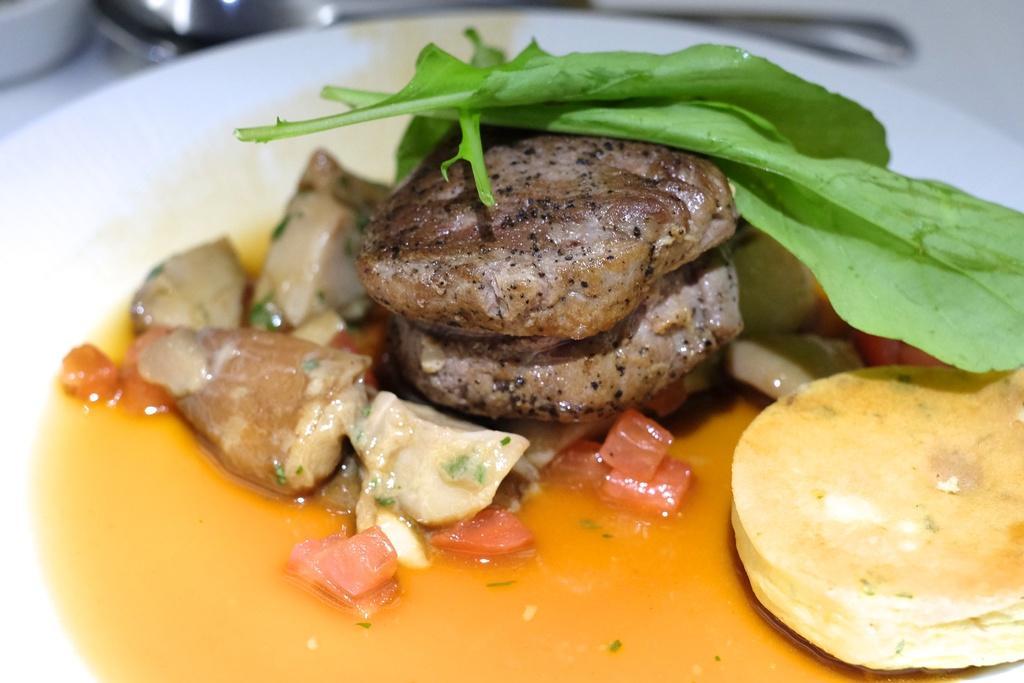How would you summarize this image in a sentence or two? In this image, we can see some food on the plate. 